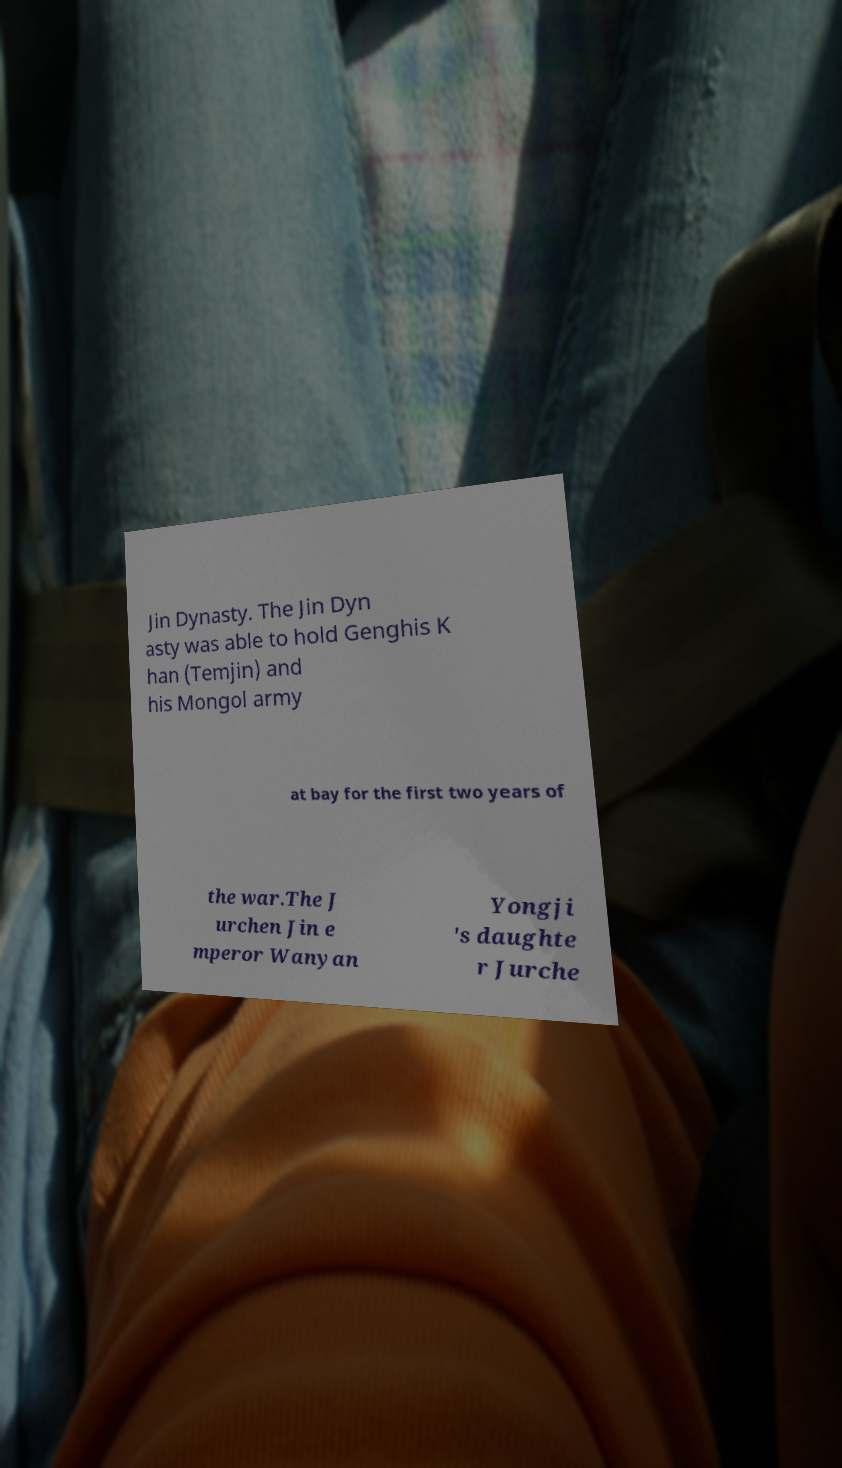I need the written content from this picture converted into text. Can you do that? Jin Dynasty. The Jin Dyn asty was able to hold Genghis K han (Temjin) and his Mongol army at bay for the first two years of the war.The J urchen Jin e mperor Wanyan Yongji 's daughte r Jurche 